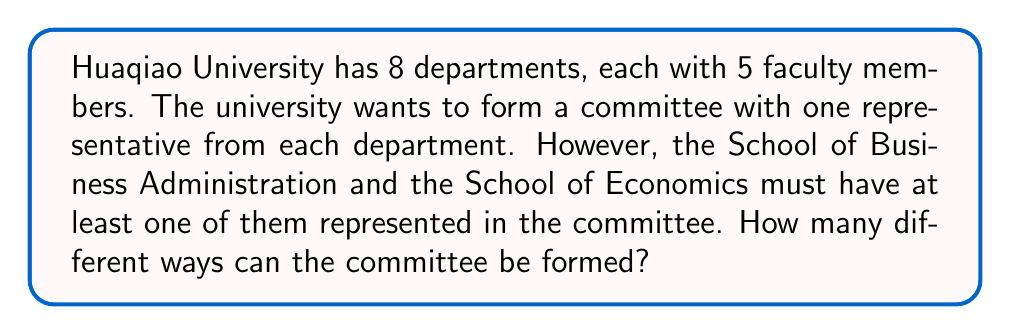Show me your answer to this math problem. Let's approach this step-by-step:

1) First, let's consider the total number of ways to form a committee without any restrictions:
   
   $$8 \text{ departments} \times 5 \text{ faculty members each} = 5^8 \text{ ways}$$

2) Now, we need to subtract the number of committees that don't include either the School of Business Administration or the School of Economics:
   
   $$\text{Committees without either school} = 6^8$$

3) Using the Principle of Inclusion-Exclusion, we can express our answer as:

   $$\text{Total committees} = \text{All possible committees} - \text{Committees without either school}$$

4) Substituting the values:

   $$\text{Total committees} = 5^8 - 6^8$$

5) Calculating:
   
   $$5^8 = 390625$$
   $$6^8 = 1679616$$

6) Therefore:

   $$\text{Total committees} = 390625 - 1679616 = 1289009$$
Answer: 1289009 